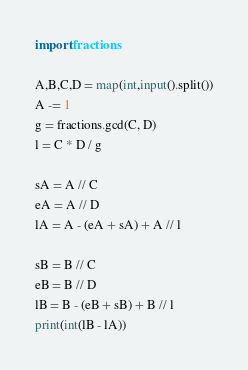Convert code to text. <code><loc_0><loc_0><loc_500><loc_500><_Python_>import fractions

A,B,C,D = map(int,input().split())
A -= 1
g = fractions.gcd(C, D)
l = C * D / g

sA = A // C
eA = A // D
lA = A - (eA + sA) + A // l

sB = B // C
eB = B // D
lB = B - (eB + sB) + B // l
print(int(lB - lA))
</code> 